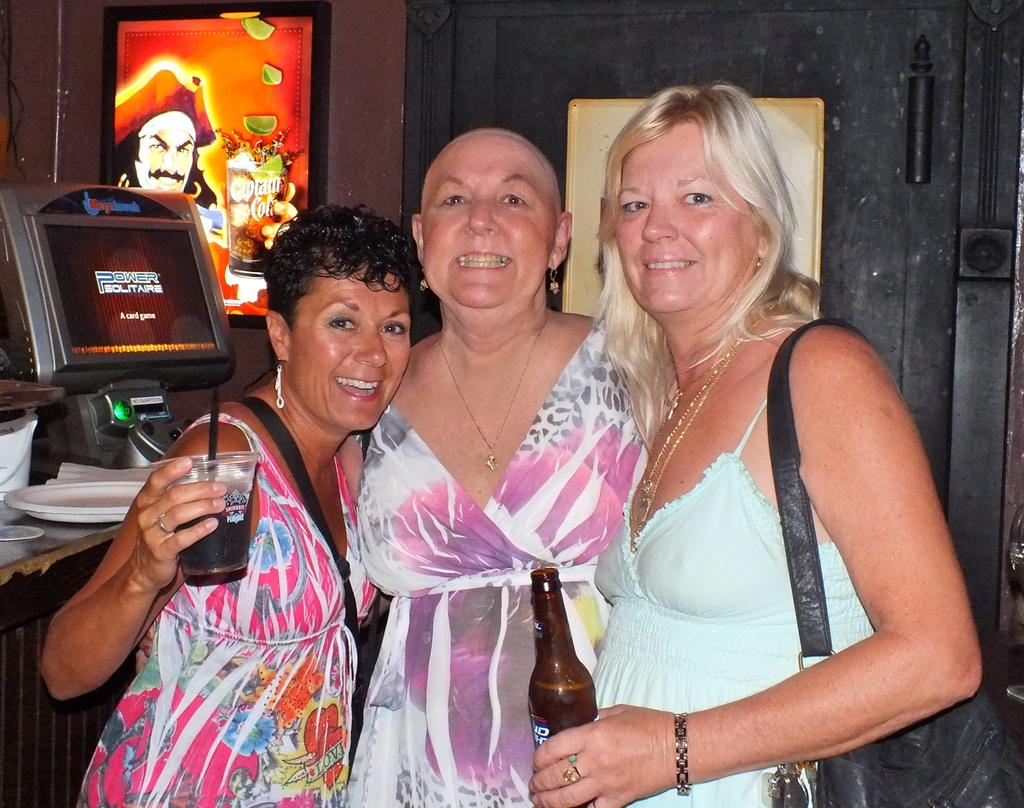How many women are present in the image? There are three women in the image. What is the facial expression of the women? The women are smiling. What is the woman on the right side holding? The woman on the right side is holding a wine bottle. What can be seen on the left side of the image? There is a monitor screen on the left side of the image. What type of exchange is taking place between the women and the grandmother in the image? There is no grandmother present in the image, and no exchange is depicted. 